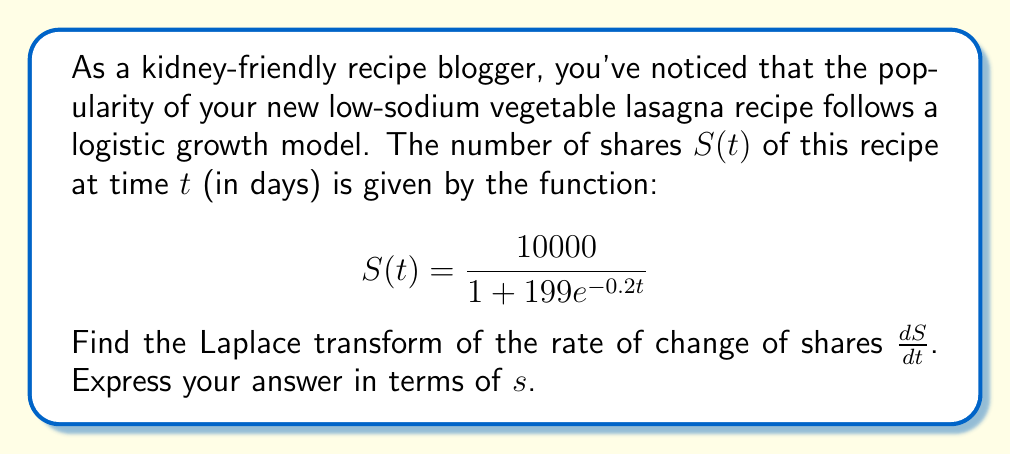Show me your answer to this math problem. Let's approach this step-by-step:

1) First, we need to find $\frac{dS}{dt}$. Using the chain rule:

   $$\frac{dS}{dt} = \frac{10000 \cdot 199 \cdot 0.2e^{-0.2t}}{(1 + 199e^{-0.2t})^2}$$

2) Simplify this expression:

   $$\frac{dS}{dt} = \frac{398000e^{-0.2t}}{(1 + 199e^{-0.2t})^2}$$

3) Now, we need to find the Laplace transform of this function. Let's denote it as $L\{\frac{dS}{dt}\}$.

4) The Laplace transform of this function is not straightforward due to the denominator. However, we can use the following property of Laplace transforms:

   $$L\{\frac{dS}{dt}\} = sL\{S(t)\} - S(0)$$

5) We know $S(t)$, so let's find $L\{S(t)\}$:

   $$L\{S(t)\} = L\{\frac{10000}{1 + 199e^{-0.2t}}\}$$

6) This is the Laplace transform of a logistic function. The general form is:

   $$L\{\frac{K}{1 + ae^{-bt}}\} = \frac{K}{s} - \frac{Ka}{s(s+b)}$$

7) In our case, $K = 10000$, $a = 199$, and $b = 0.2$. Substituting:

   $$L\{S(t)\} = \frac{10000}{s} - \frac{1990000}{s(s+0.2)}$$

8) Now, let's use the property from step 4:

   $$L\{\frac{dS}{dt}\} = s(\frac{10000}{s} - \frac{1990000}{s(s+0.2)}) - S(0)$$

9) Simplify:

   $$L\{\frac{dS}{dt}\} = 10000 - \frac{1990000}{s+0.2} - S(0)$$

10) Calculate $S(0)$:

    $$S(0) = \frac{10000}{1 + 199} = 50$$

11) Substitute this back:

    $$L\{\frac{dS}{dt}\} = 10000 - \frac{1990000}{s+0.2} - 50$$

12) Final simplification:

    $$L\{\frac{dS}{dt}\} = 9950 - \frac{1990000}{s+0.2}$$
Answer: $$9950 - \frac{1990000}{s+0.2}$$ 